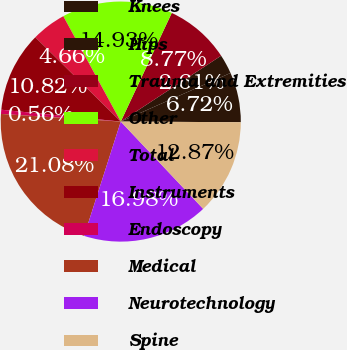Convert chart to OTSL. <chart><loc_0><loc_0><loc_500><loc_500><pie_chart><fcel>Knees<fcel>Hips<fcel>Trauma and Extremities<fcel>Other<fcel>Total<fcel>Instruments<fcel>Endoscopy<fcel>Medical<fcel>Neurotechnology<fcel>Spine<nl><fcel>6.72%<fcel>2.61%<fcel>8.77%<fcel>14.93%<fcel>4.66%<fcel>10.82%<fcel>0.56%<fcel>21.08%<fcel>16.98%<fcel>12.87%<nl></chart> 